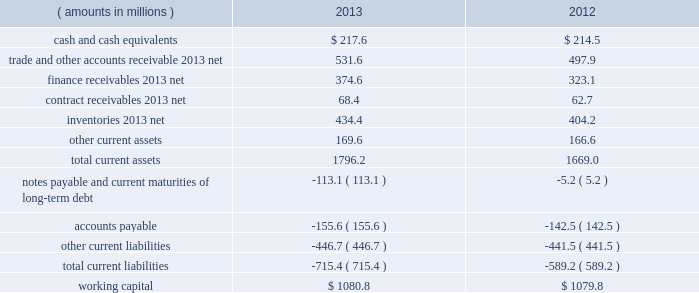Management 2019s discussion and analysis of financial condition and results of operations ( continued ) liquidity and capital resources snap-on 2019s growth has historically been funded by a combination of cash provided by operating activities and debt financing .
Snap-on believes that its cash from operations and collections of finance receivables , coupled with its sources of borrowings and available cash on hand , are sufficient to fund its currently anticipated requirements for scheduled debt payments ( including the march 2014 repayment of $ 100.0 million of 5.85% ( 5.85 % ) unsecured notes upon maturity ) , payments of interest and dividends , new receivables originated by our financial services businesses , capital expenditures , working capital , restructuring activities , the funding of pension plans , and funding for additional share repurchases and acquisitions , if any .
Due to snap-on 2019s credit rating over the years , external funds have been available at an acceptable cost .
As of the close of business on february 7 , 2014 , snap-on 2019s long-term debt and commercial paper were rated , respectively , a3 and p-2 by moody 2019s investors service ; a- and a-2 by standard & poor 2019s ; and a- and f2 by fitch ratings .
Snap-on believes that its current credit arrangements are sound and that the strength of its balance sheet affords the company the financial flexibility to respond to both internal growth opportunities and those available through acquisitions .
However , snap-on cannot provide any assurances of the availability of future financing or the terms on which it might be available , or that its debt ratings may not decrease .
The following discussion focuses on information included in the accompanying consolidated balance sheets .
As of 2013 year end , working capital ( current assets less current liabilities ) of $ 1080.8 million increased $ 1.0 million from $ 1079.8 million as of 2012 year end .
The following represents the company 2019s working capital position as of 2013 and 2012 year end : ( amounts in millions ) 2013 2012 .
Cash and cash equivalents of $ 217.6 million as of 2013 year end compared to cash and cash equivalents of $ 214.5 million at 2012 year end .
The $ 3.1 million net increase in cash and cash equivalents includes the impacts of ( i ) $ 508.8 million of cash from collections of finance receivables ; ( ii ) $ 392.6 million of cash generated from operations , net of $ 24.3 million of discretionary cash contributions to the company 2019s pension plans ; ( iii ) $ 29.2 million of cash proceeds from stock purchase and option plan exercises ; and ( iv ) $ 8.4 million of cash proceeds from the sale of property and equipment .
These increases in cash and cash equivalents were largely offset by ( i ) the funding of $ 651.3 million of new finance receivables ; ( ii ) dividend payments to shareholders of $ 92.0 million ; ( iii ) the repurchase of 926000 shares of the company 2019s common stock for $ 82.6 million ; ( iv ) the funding of $ 70.6 million of capital expenditures ; and ( v ) the may 2013 acquisition of challenger for a cash purchase price of $ 38.2 million .
Of the $ 217.6 million of cash and cash equivalents as of 2013 year end , $ 124.3 million was held outside of the united states .
Snap-on considers these non-u.s .
Funds as permanently invested in its foreign operations to ( i ) provide adequate working capital ; ( ii ) satisfy various regulatory requirements ; and/or ( iii ) take advantage of business expansion opportunities as they arise ; as such , the company does not presently expect to repatriate these funds to fund its u.s .
Operations or obligations .
The repatriation of cash from certain foreign subsidiaries could have adverse net tax consequences on the company should snap-on be required to pay and record u.s .
Income taxes and foreign withholding taxes on funds that were previously considered permanently invested .
Alternatively , the repatriation of such cash from certain other foreign subsidiaries could result in favorable net tax consequences for the company .
Snap-on periodically evaluates opportunities to repatriate certain foreign cash amounts to the extent that it does not incur additional unfavorable net tax consequences .
46 snap-on incorporated .
What is the percentage change in the balance of cash and cash equivalents from 2012 to 2013? 
Computations: ((217.6 - 214.5) / 214.5)
Answer: 0.01445. 